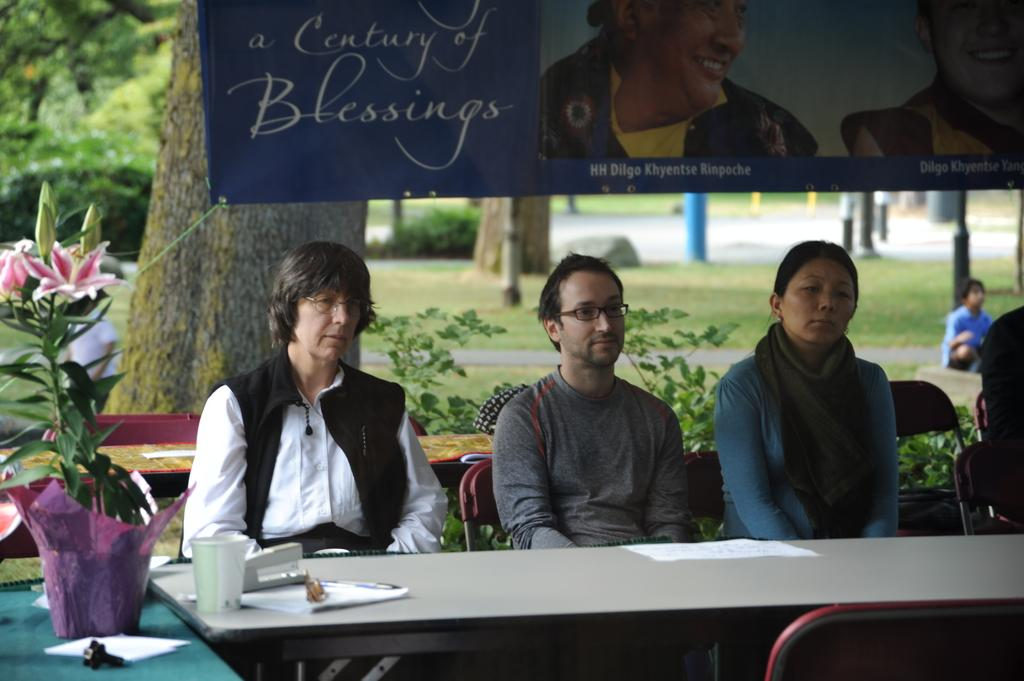How many people are sitting in the image? There are three people sitting in the image. What is in front of the people? They have a table in front of them. What can be seen on the table? There are disposable glasses and papers on the table. What is visible in the background of the image? There is a banner, a tree, and plants in the background of the image. What type of wax is being used by the sisters in the image? There are no sisters or wax present in the image. How many tomatoes are on the table in the image? There are no tomatoes present in the image. 